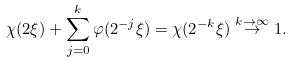<formula> <loc_0><loc_0><loc_500><loc_500>\chi ( 2 \xi ) + \sum _ { j = 0 } ^ { k } \varphi ( 2 ^ { - j } \xi ) = \chi ( 2 ^ { - k } \xi ) \stackrel { k \to \infty } { \to } 1 .</formula> 